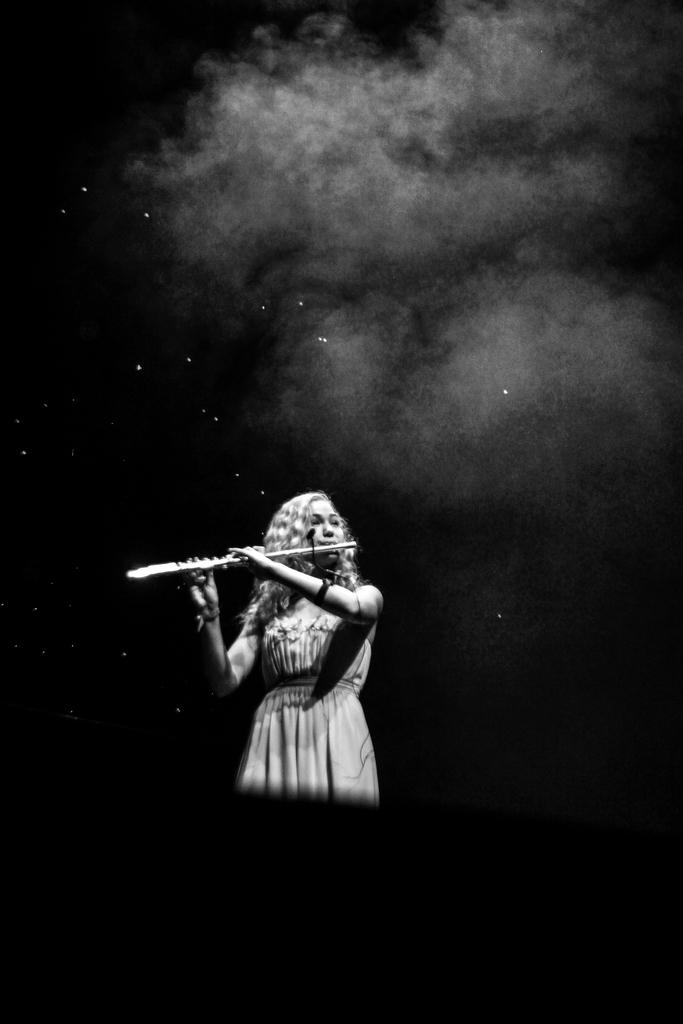Who is the main subject in the image? There is a woman in the center of the image. What is the woman doing in the image? The woman is playing a musical instrument. What can be seen at the top of the image? There is smoke visible at the top of the image. How would you describe the lighting in the image? The area around the woman is dark. What type of bread can be seen in the image? There is no bread present in the image. What is the purpose of the protest in the image? There is no protest depicted in the image; it features a woman playing a musical instrument. 